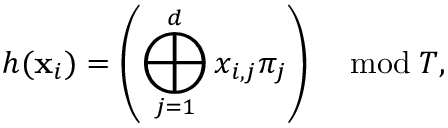Convert formula to latex. <formula><loc_0><loc_0><loc_500><loc_500>h ( x _ { i } ) = \left ( \bigoplus _ { j = 1 } ^ { d } x _ { i , j } \pi _ { j } \right ) \quad \bmod T ,</formula> 